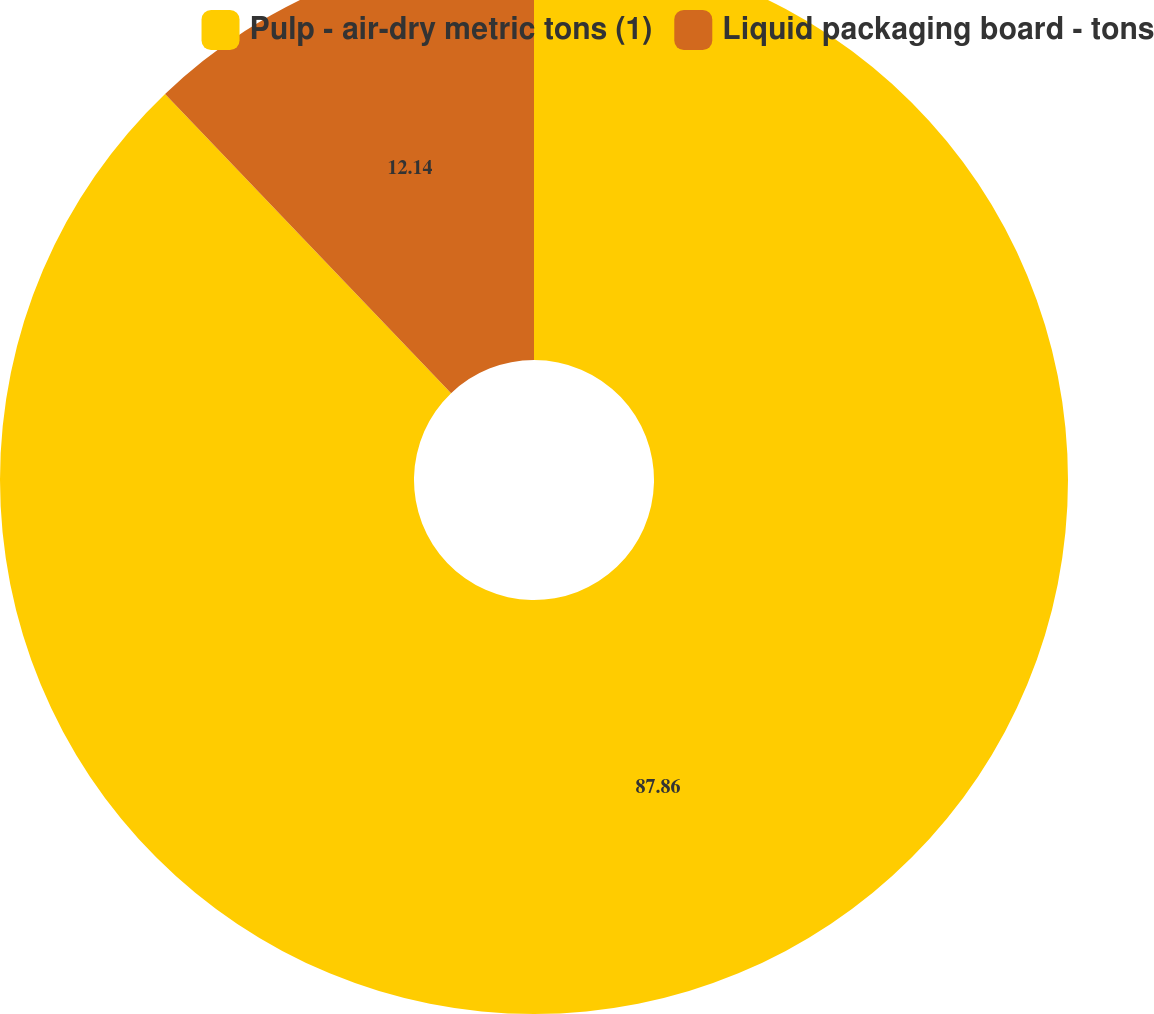Convert chart to OTSL. <chart><loc_0><loc_0><loc_500><loc_500><pie_chart><fcel>Pulp - air-dry metric tons (1)<fcel>Liquid packaging board - tons<nl><fcel>87.86%<fcel>12.14%<nl></chart> 